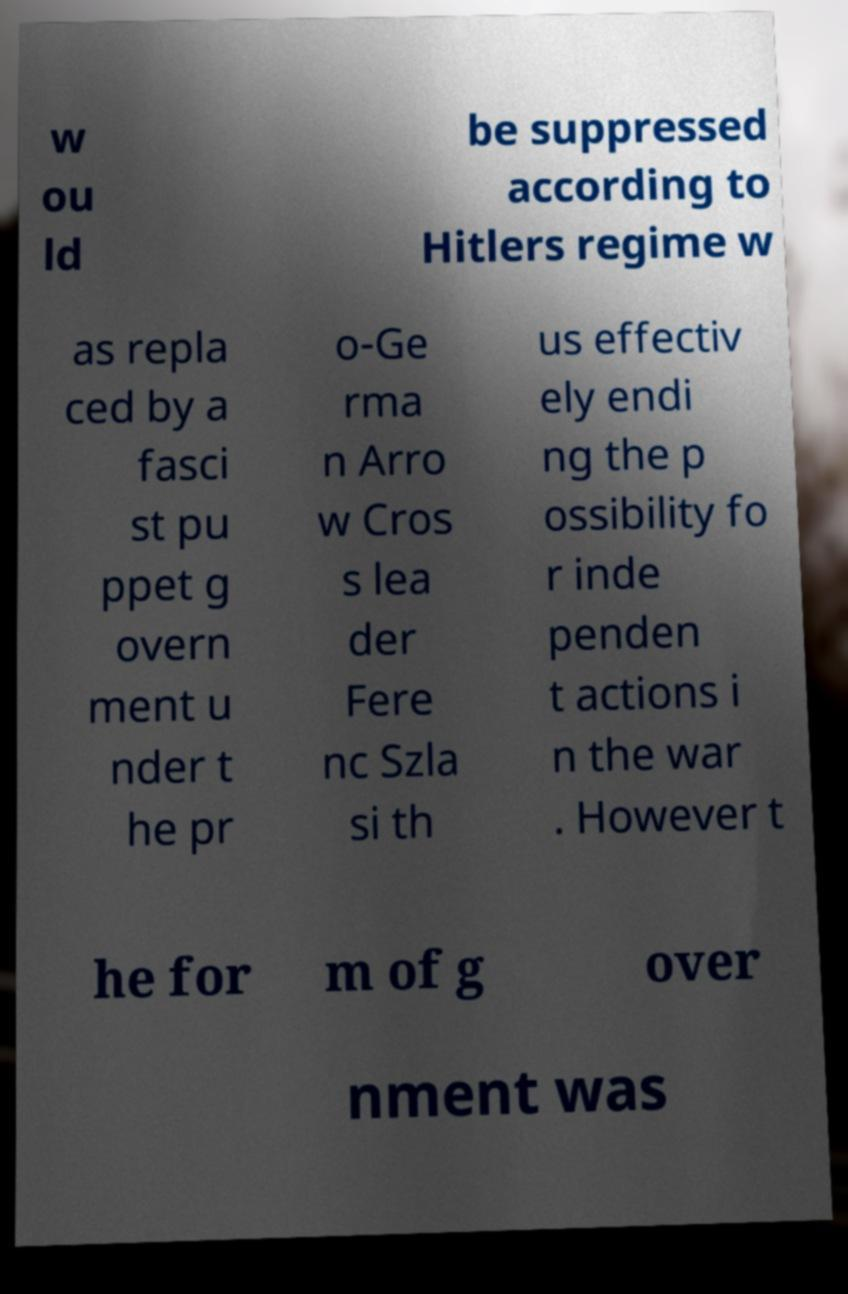Could you extract and type out the text from this image? w ou ld be suppressed according to Hitlers regime w as repla ced by a fasci st pu ppet g overn ment u nder t he pr o-Ge rma n Arro w Cros s lea der Fere nc Szla si th us effectiv ely endi ng the p ossibility fo r inde penden t actions i n the war . However t he for m of g over nment was 